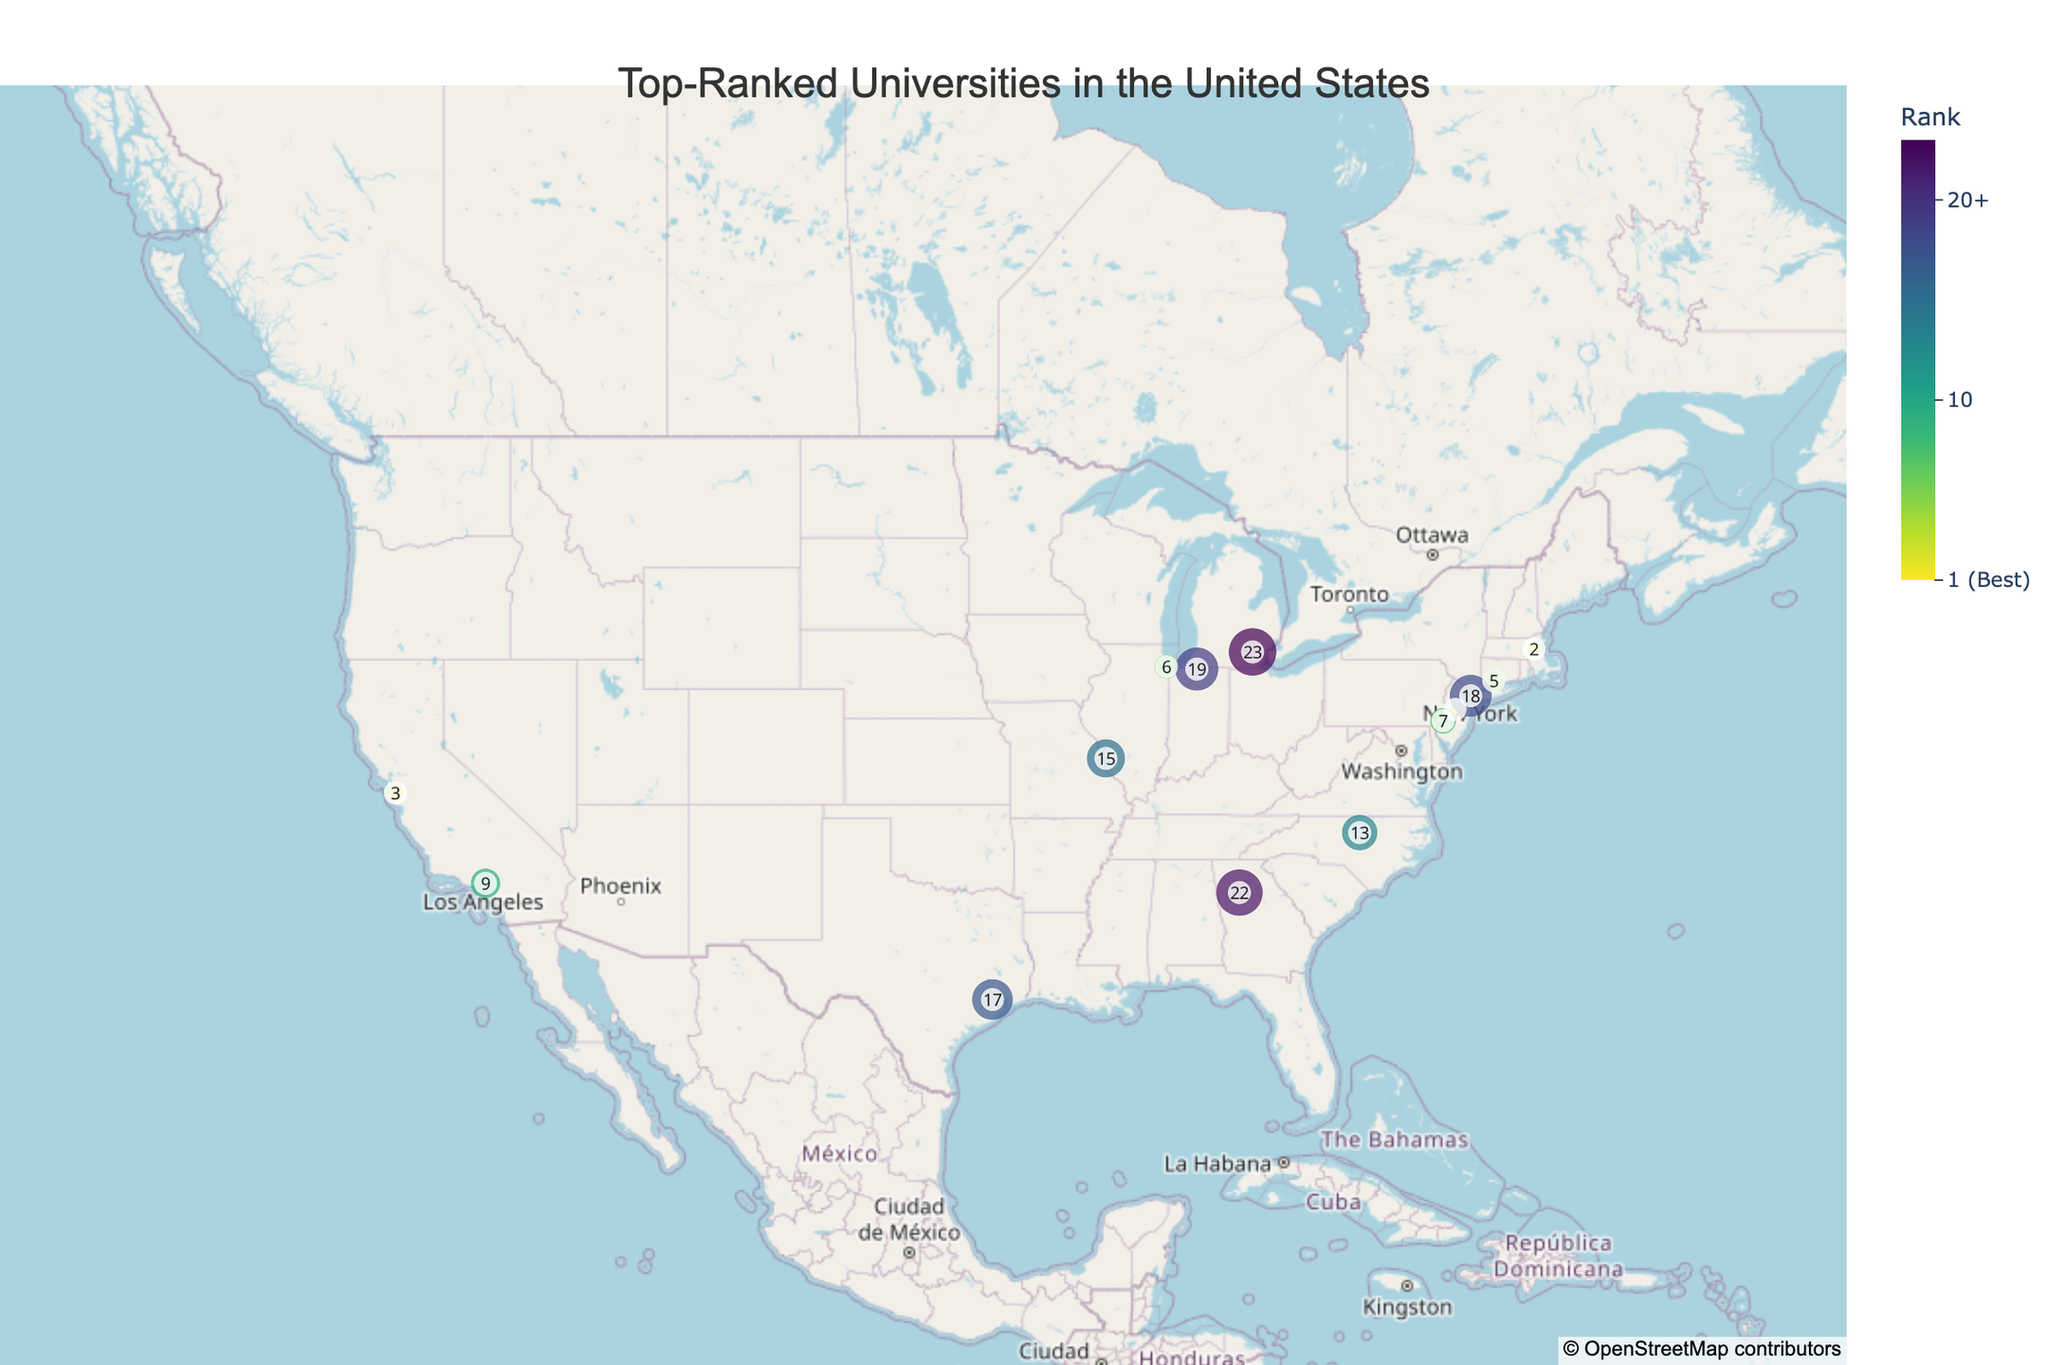What's the title of the figure? The title is usually found at the top of the figure and describes the main content of the visualization. In this case, it states "Top-Ranked Universities in the United States".
Answer: Top-Ranked Universities in the United States What is the color scheme used for the ranking in the plot? The color scheme is represented in a continuous color bar, typically found alongside the plot. The caption at the top of this bar indicates the scale used. Here, the plot uses a sequential palette that ranges from dark to light, labeled as "Viridis_r".
Answer: A sequential Viridis_r palette Which university is ranked number 1? By looking at the scatter plot and identifying the point where the hover information shows "Rank: 1", we can find the top university. In this plot, the university ranked number 1 is Princeton University.
Answer: Princeton University How many universities are represented in California? To determine this, count the number of data points located within the geographic boundaries of California. Based on the plot, there are two universities in California: Stanford University and California Institute of Technology.
Answer: Two Which university is ranked higher, University of Michigan or Emory University? To find this information, compare the ranks shown for University of Michigan and Emory University in the hover data or labels. University of Michigan is ranked 23, while Emory University is ranked 22, indicating Emory has a higher (better) rank.
Answer: Emory University Which state has the highest number of top-ranked universities represented in the plot? By examining the plot and noticing clusters of data points within state boundaries, we can determine which state has the most universities. California has two universities, while others have only one each.
Answer: California What is the positional difference in latitude between Harvard University and Duke University? By checking the specific latitude values for Harvard University (42.3744) and Duke University (36.0014), and calculating their difference, we get the positional difference in latitude. 42.3744 - 36.0014 = 6.373
Answer: 6.373 Are there any top-ranked universities in Nebraska represented in this plot? Inspecting the geographical region corresponding to Nebraska on the plot reveals no data points, indicating no top-ranked universities from Nebraska are represented.
Answer: No Which university is furthest west? By identifying the universities with the most negative longitude values, which correspond to western locations, we see that Stanford University (Longitude: -122.1697) is the furthest west.
Answer: Stanford University Which university is closest to Washington, D.C.? To determine this, find the university located nearest to the latitude (approximately 38.9072) and longitude (approximately -77.0369) of Washington, D.C. The University of Pennsylvania located at (39.9522, -75.1932) is the closest.
Answer: University of Pennsylvania 